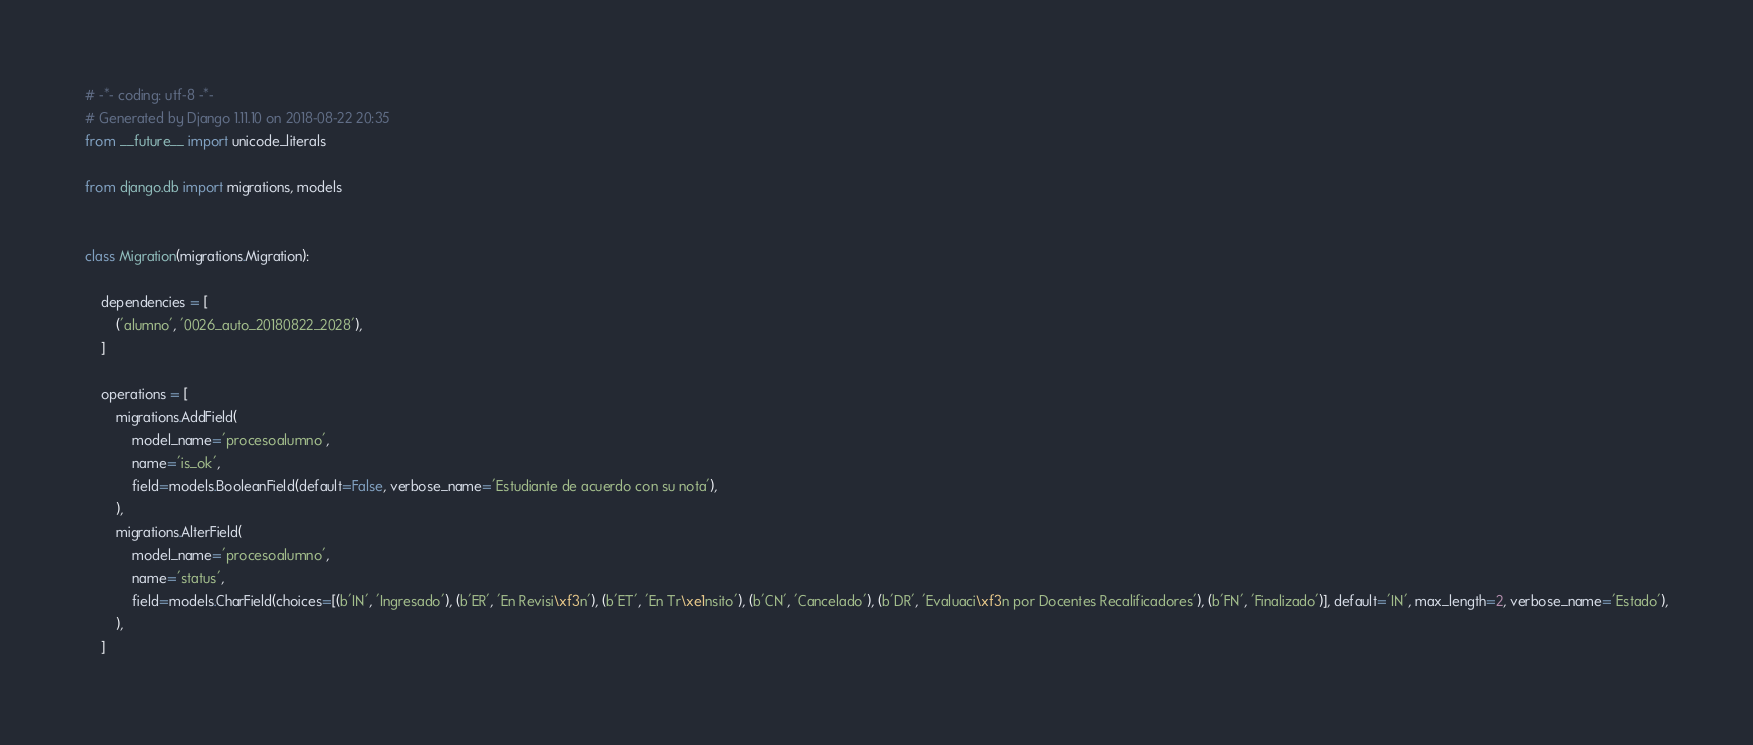Convert code to text. <code><loc_0><loc_0><loc_500><loc_500><_Python_># -*- coding: utf-8 -*-
# Generated by Django 1.11.10 on 2018-08-22 20:35
from __future__ import unicode_literals

from django.db import migrations, models


class Migration(migrations.Migration):

    dependencies = [
        ('alumno', '0026_auto_20180822_2028'),
    ]

    operations = [
        migrations.AddField(
            model_name='procesoalumno',
            name='is_ok',
            field=models.BooleanField(default=False, verbose_name='Estudiante de acuerdo con su nota'),
        ),
        migrations.AlterField(
            model_name='procesoalumno',
            name='status',
            field=models.CharField(choices=[(b'IN', 'Ingresado'), (b'ER', 'En Revisi\xf3n'), (b'ET', 'En Tr\xe1nsito'), (b'CN', 'Cancelado'), (b'DR', 'Evaluaci\xf3n por Docentes Recalificadores'), (b'FN', 'Finalizado')], default='IN', max_length=2, verbose_name='Estado'),
        ),
    ]
</code> 